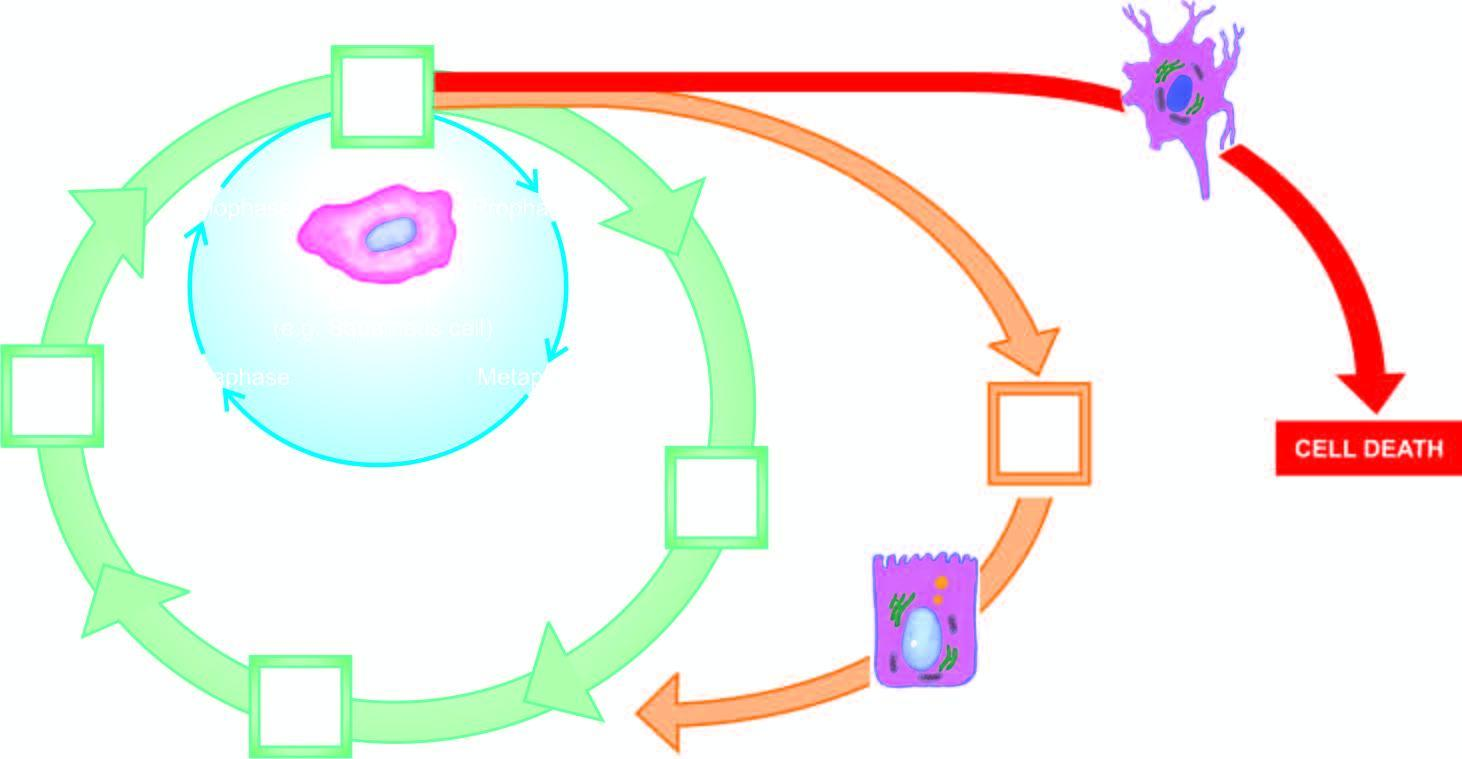what represents cell cycle for stable cells?
Answer the question using a single word or phrase. Circle shown with yellow-orange line 